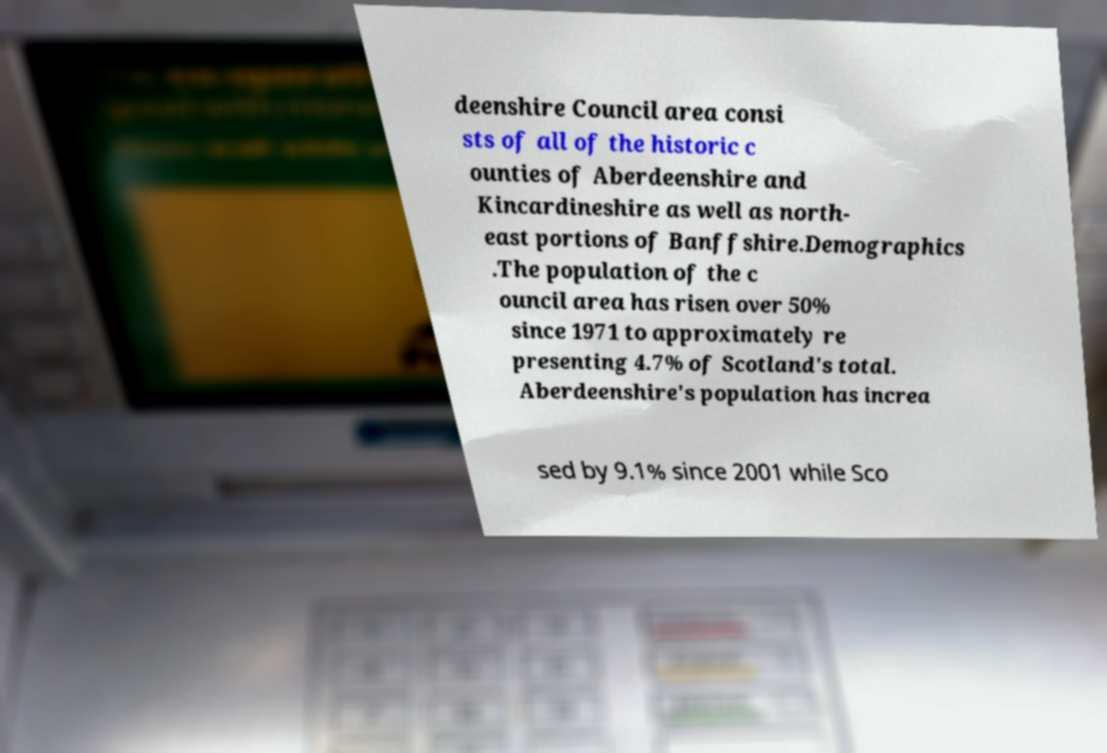What messages or text are displayed in this image? I need them in a readable, typed format. deenshire Council area consi sts of all of the historic c ounties of Aberdeenshire and Kincardineshire as well as north- east portions of Banffshire.Demographics .The population of the c ouncil area has risen over 50% since 1971 to approximately re presenting 4.7% of Scotland's total. Aberdeenshire's population has increa sed by 9.1% since 2001 while Sco 